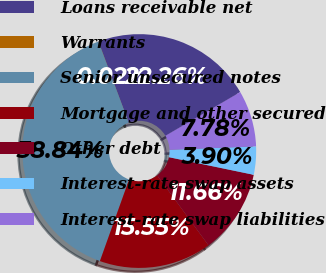Convert chart. <chart><loc_0><loc_0><loc_500><loc_500><pie_chart><fcel>Loans receivable net<fcel>Warrants<fcel>Senior unsecured notes<fcel>Mortgage and other secured<fcel>Other debt<fcel>Interest-rate swap assets<fcel>Interest-rate swap liabilities<nl><fcel>22.26%<fcel>0.02%<fcel>38.84%<fcel>15.55%<fcel>11.66%<fcel>3.9%<fcel>7.78%<nl></chart> 